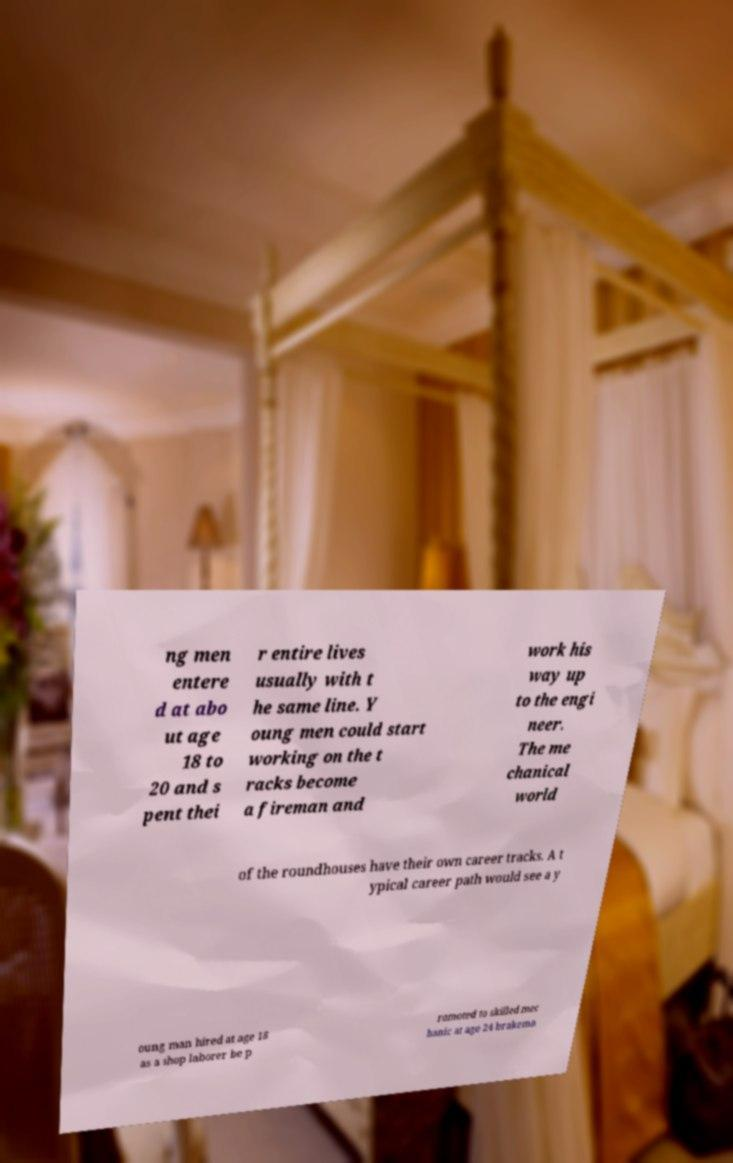Can you accurately transcribe the text from the provided image for me? ng men entere d at abo ut age 18 to 20 and s pent thei r entire lives usually with t he same line. Y oung men could start working on the t racks become a fireman and work his way up to the engi neer. The me chanical world of the roundhouses have their own career tracks. A t ypical career path would see a y oung man hired at age 18 as a shop laborer be p romoted to skilled mec hanic at age 24 brakema 